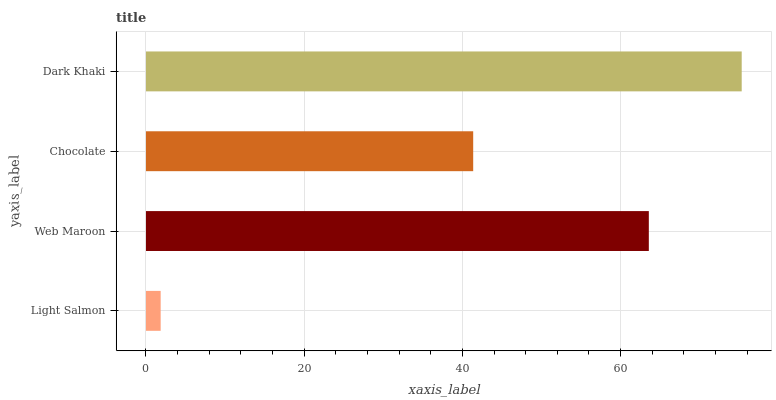Is Light Salmon the minimum?
Answer yes or no. Yes. Is Dark Khaki the maximum?
Answer yes or no. Yes. Is Web Maroon the minimum?
Answer yes or no. No. Is Web Maroon the maximum?
Answer yes or no. No. Is Web Maroon greater than Light Salmon?
Answer yes or no. Yes. Is Light Salmon less than Web Maroon?
Answer yes or no. Yes. Is Light Salmon greater than Web Maroon?
Answer yes or no. No. Is Web Maroon less than Light Salmon?
Answer yes or no. No. Is Web Maroon the high median?
Answer yes or no. Yes. Is Chocolate the low median?
Answer yes or no. Yes. Is Light Salmon the high median?
Answer yes or no. No. Is Dark Khaki the low median?
Answer yes or no. No. 